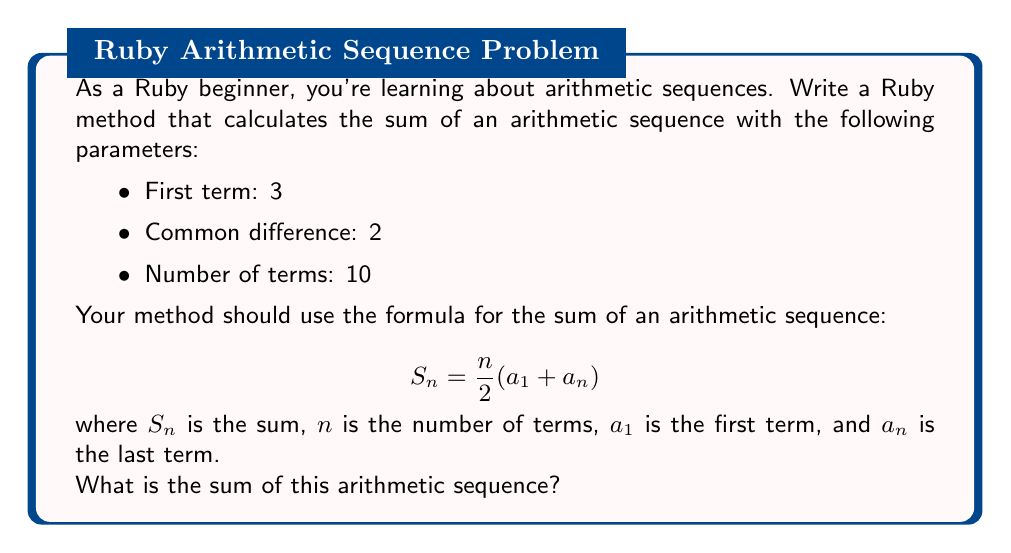Can you solve this math problem? Let's break this down step-by-step:

1. First, we need to identify the values:
   - $a_1 = 3$ (first term)
   - $d = 2$ (common difference)
   - $n = 10$ (number of terms)

2. To use the formula, we need to find $a_n$ (the last term):
   $a_n = a_1 + (n-1)d$
   $a_n = 3 + (10-1)2 = 3 + 18 = 21$

3. Now we can apply the formula:
   $$ S_n = \frac{n}{2}(a_1 + a_n) $$
   $$ S_{10} = \frac{10}{2}(3 + 21) $$
   $$ S_{10} = 5(24) = 120 $$

4. To implement this in Ruby, we could write a method like this:

```ruby
def arithmetic_sequence_sum(a1, d, n)
  an = a1 + (n - 1) * d
  n * (a1 + an) / 2
end

sum = arithmetic_sequence_sum(3, 2, 10)
puts sum
```

This method calculates the last term `an`, then applies the formula to find the sum.
Answer: The sum of the arithmetic sequence is 120. 